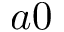<formula> <loc_0><loc_0><loc_500><loc_500>a 0</formula> 